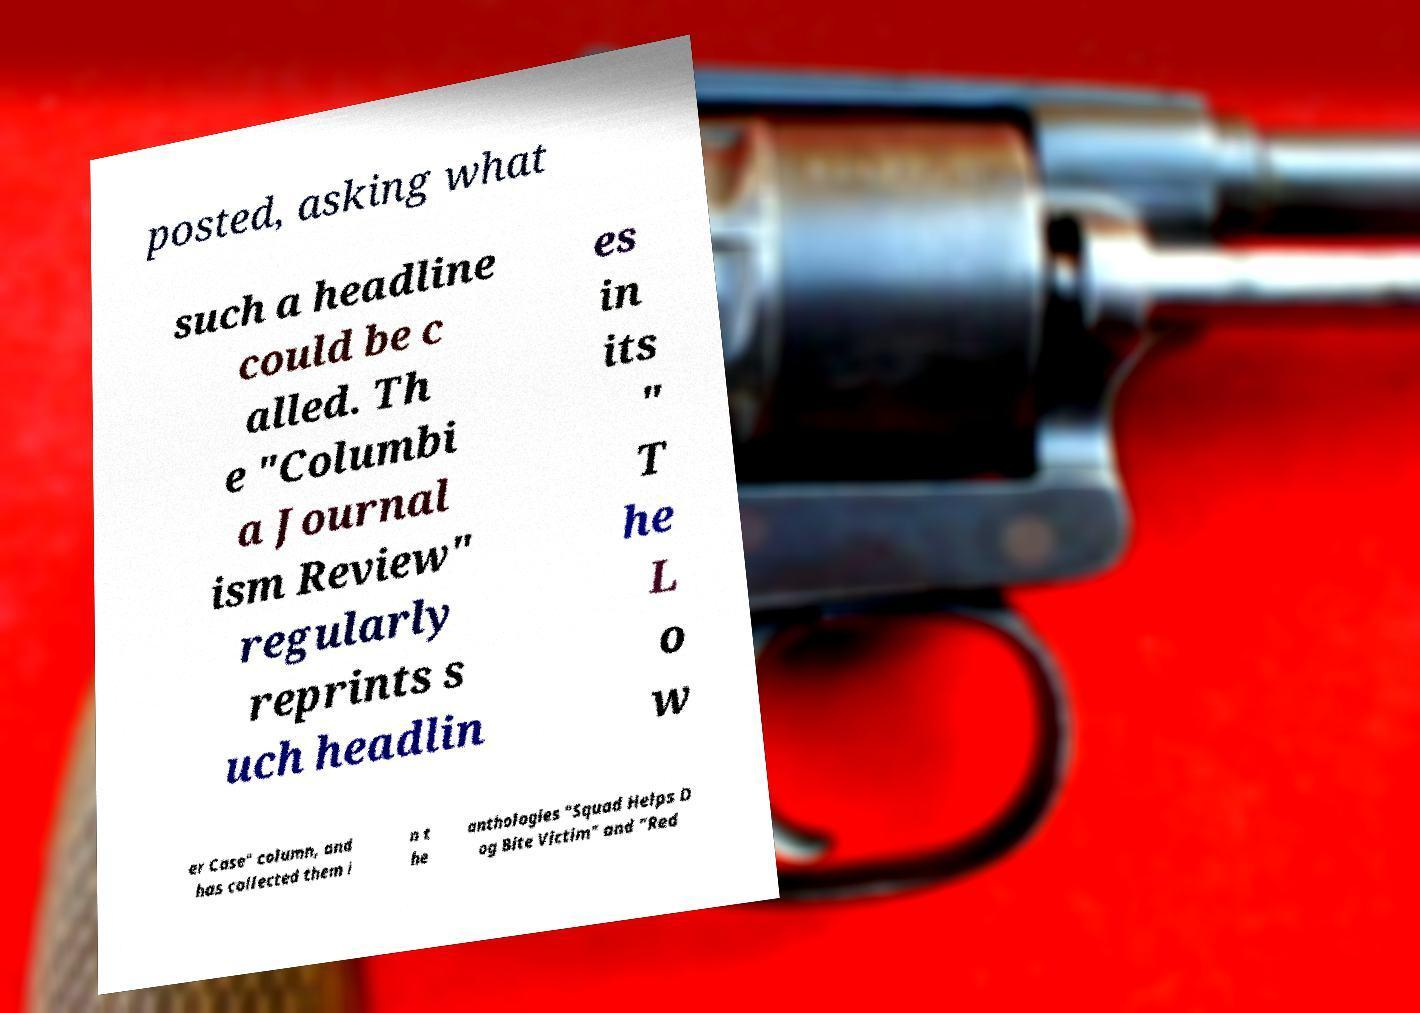Could you assist in decoding the text presented in this image and type it out clearly? posted, asking what such a headline could be c alled. Th e "Columbi a Journal ism Review" regularly reprints s uch headlin es in its " T he L o w er Case" column, and has collected them i n t he anthologies "Squad Helps D og Bite Victim" and "Red 